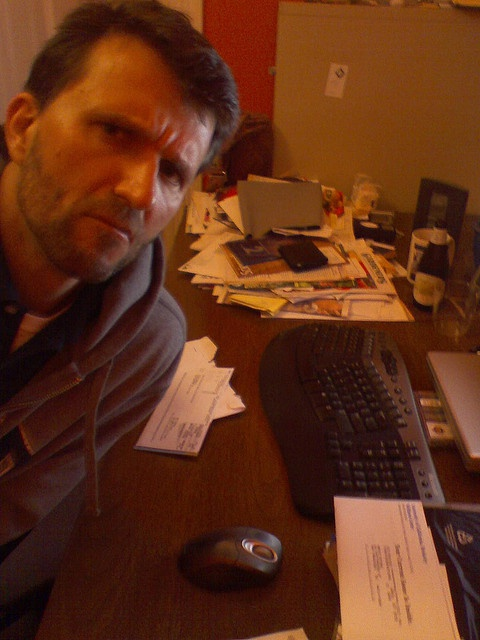Describe the objects in this image and their specific colors. I can see people in brown, black, and maroon tones, keyboard in brown, black, and maroon tones, book in brown, tan, black, salmon, and maroon tones, mouse in brown, black, maroon, and gray tones, and bottle in brown, black, and maroon tones in this image. 